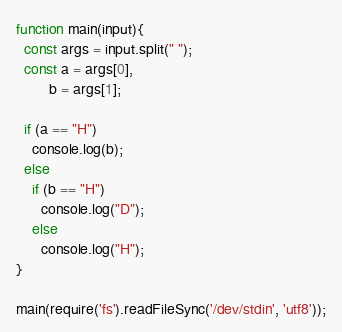Convert code to text. <code><loc_0><loc_0><loc_500><loc_500><_JavaScript_>function main(input){
  const args = input.split(" ");
  const a = args[0],
        b = args[1];
  
  if (a == "H")
    console.log(b);
  else
    if (b == "H")
      console.log("D");
    else
      console.log("H");
}

main(require('fs').readFileSync('/dev/stdin', 'utf8'));

</code> 